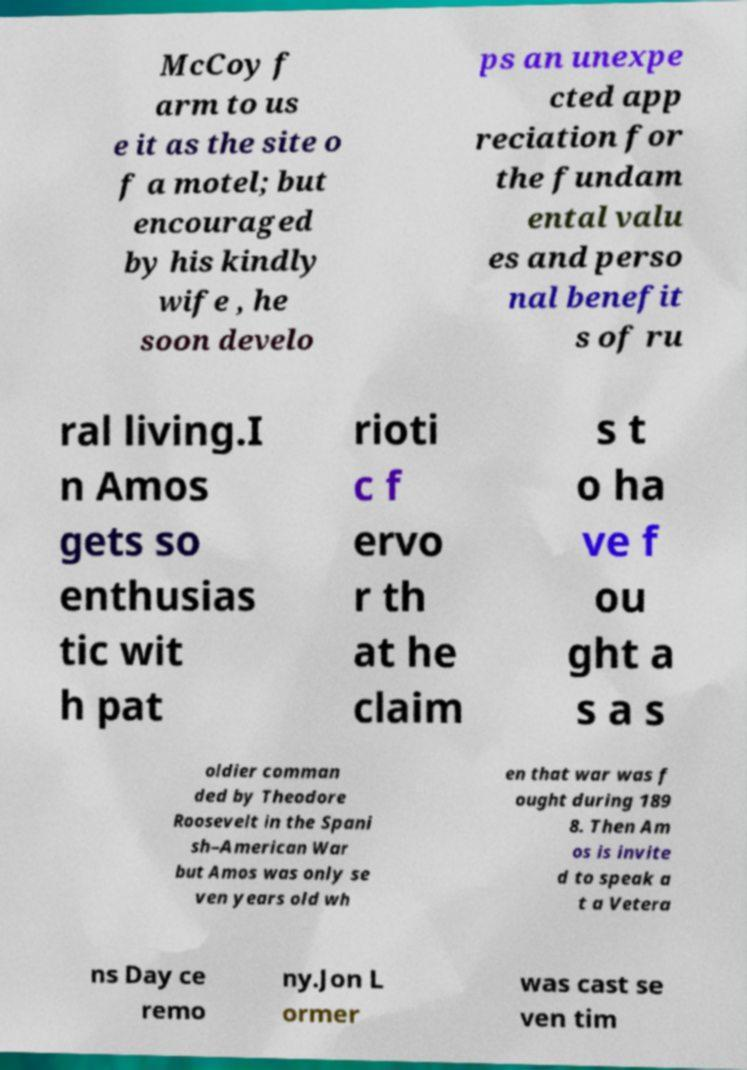There's text embedded in this image that I need extracted. Can you transcribe it verbatim? McCoy f arm to us e it as the site o f a motel; but encouraged by his kindly wife , he soon develo ps an unexpe cted app reciation for the fundam ental valu es and perso nal benefit s of ru ral living.I n Amos gets so enthusias tic wit h pat rioti c f ervo r th at he claim s t o ha ve f ou ght a s a s oldier comman ded by Theodore Roosevelt in the Spani sh–American War but Amos was only se ven years old wh en that war was f ought during 189 8. Then Am os is invite d to speak a t a Vetera ns Day ce remo ny.Jon L ormer was cast se ven tim 